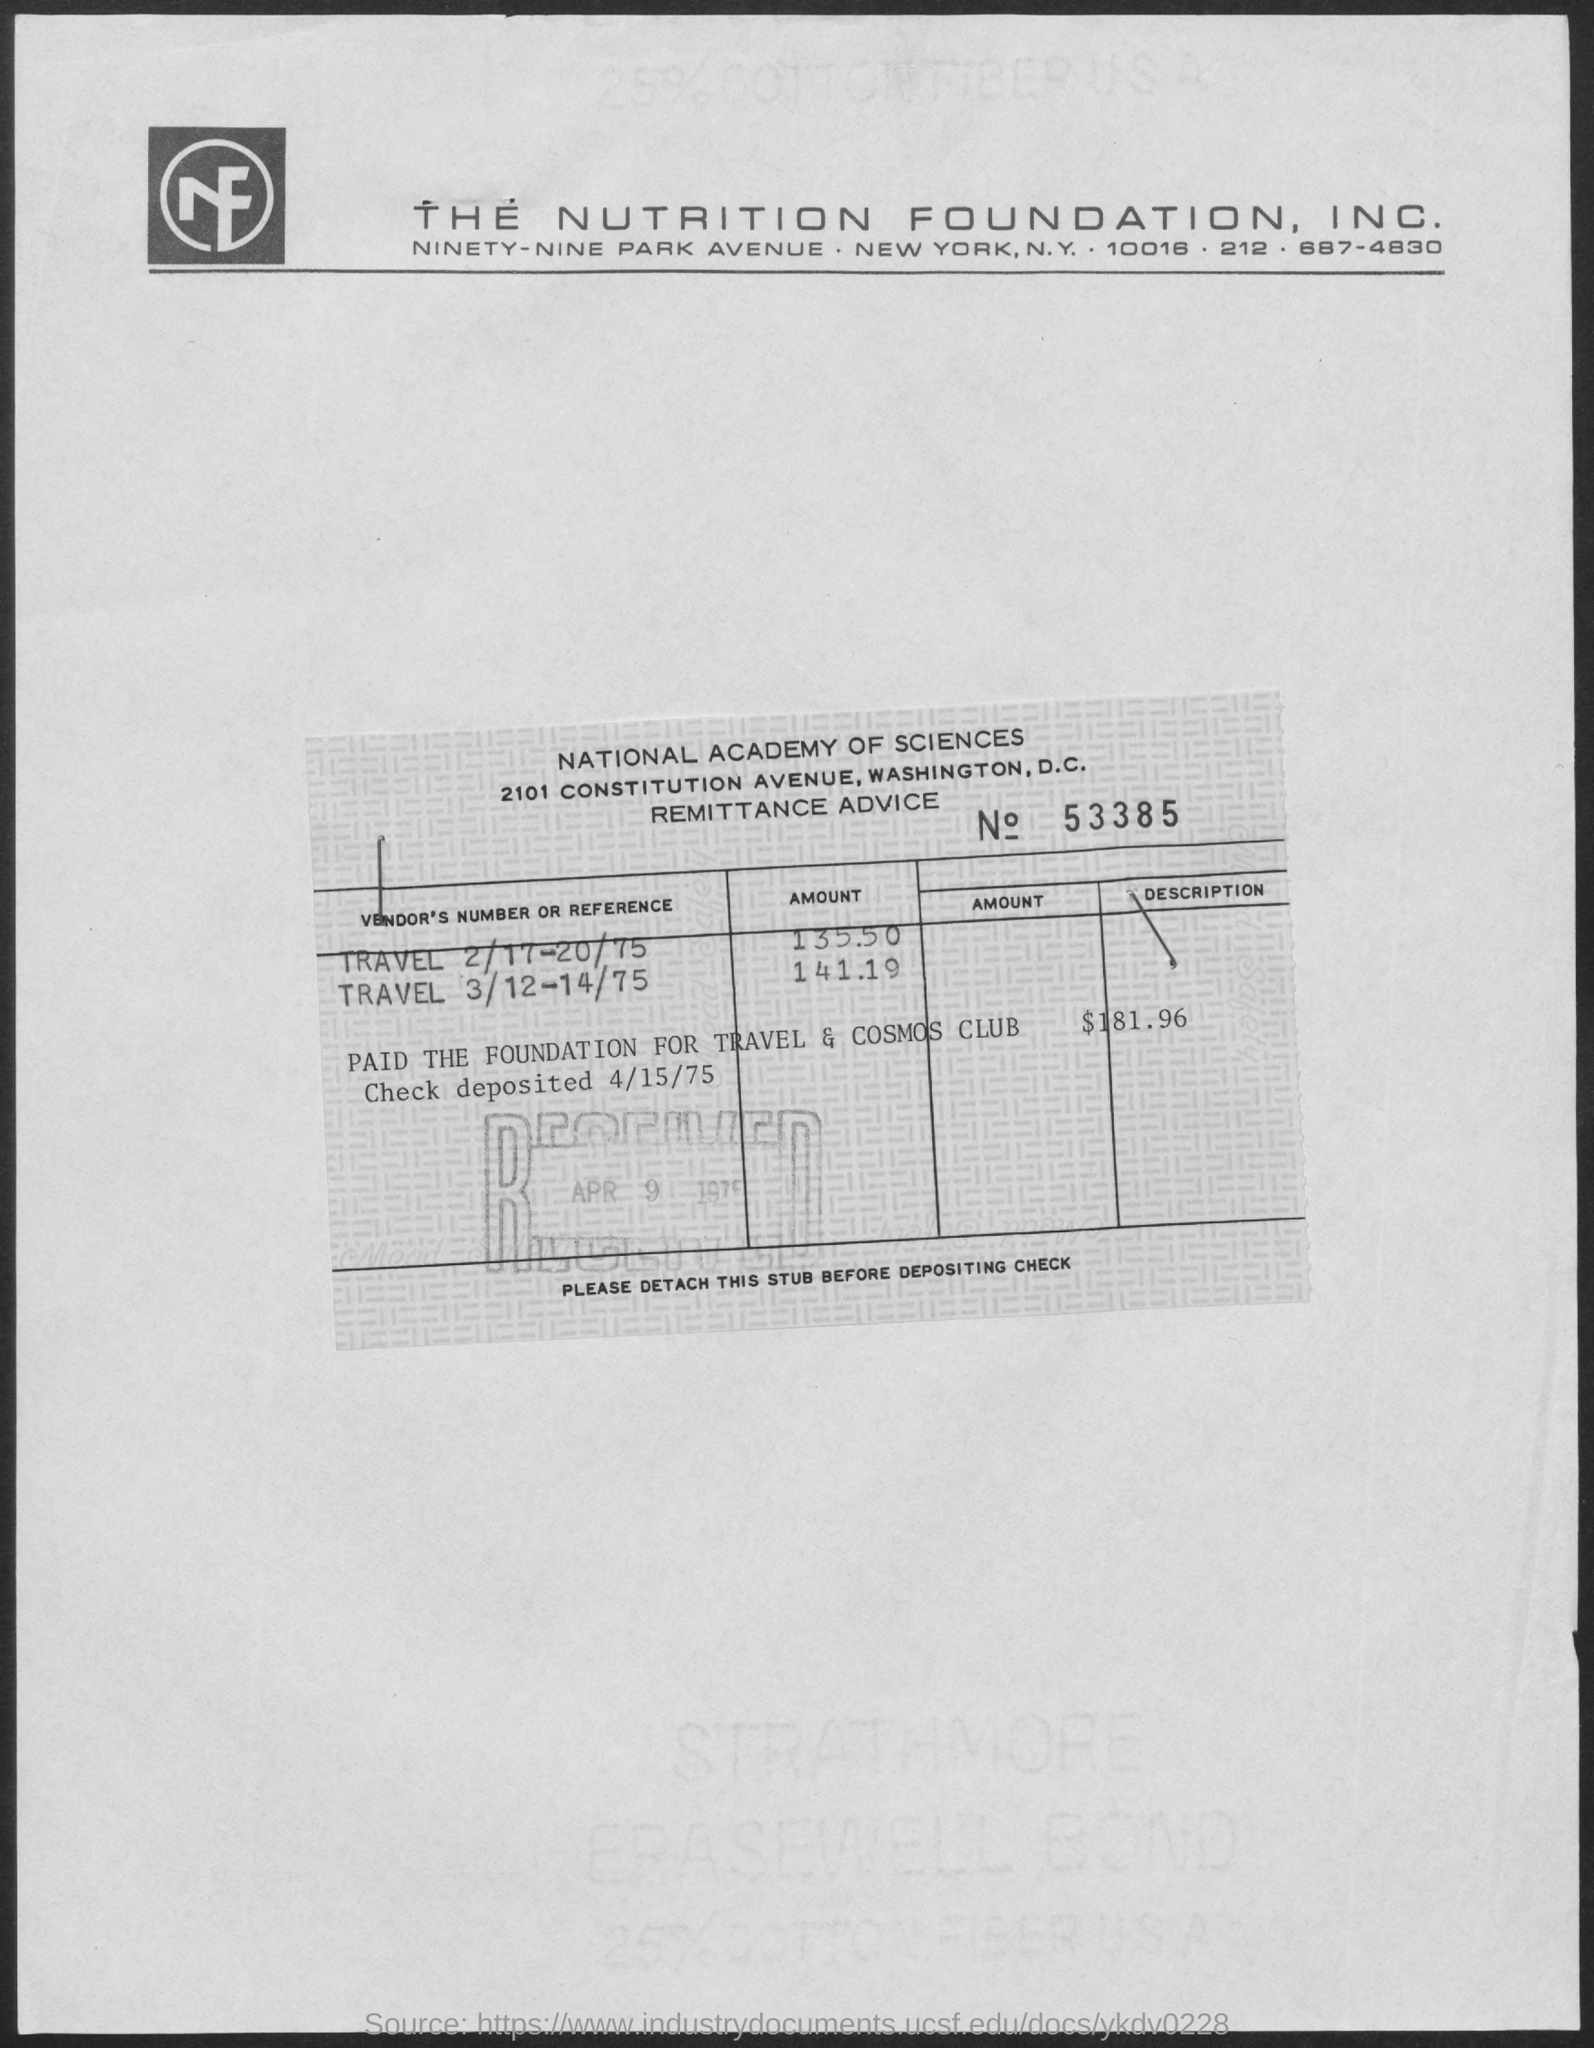Highlight a few significant elements in this photo. The document is titled 'The Nutrition Foundation, Inc.' 